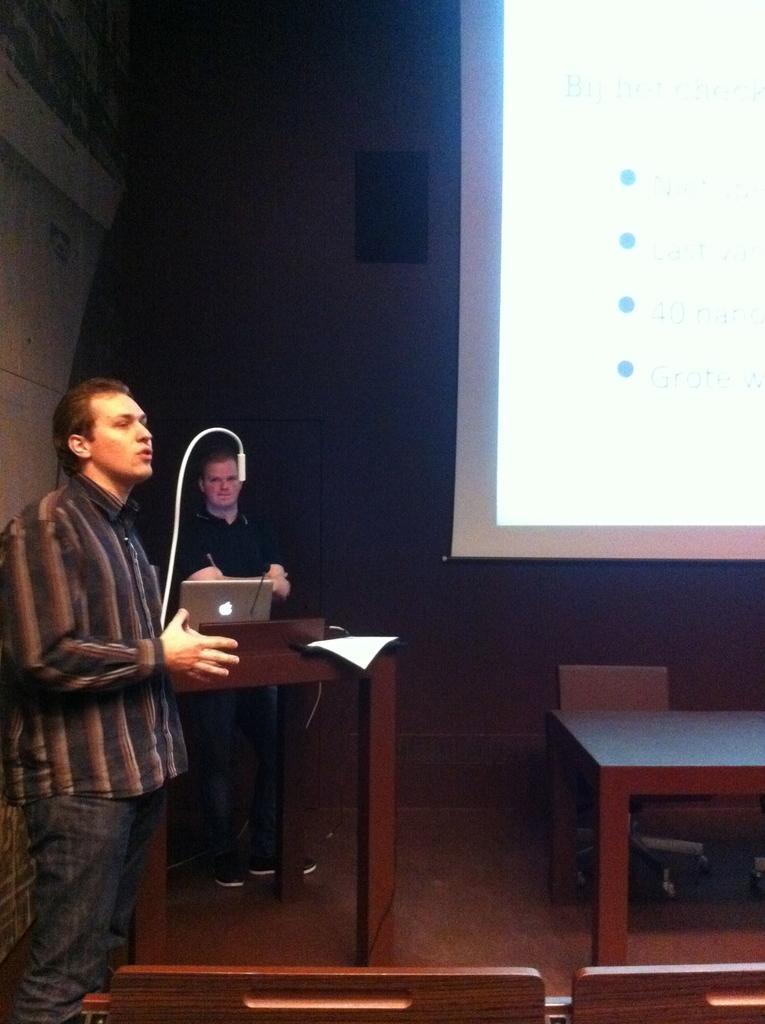How would you summarize this image in a sentence or two? In this image there is a man standing and speaking , another man standing near the podium with a laptop and in back ground there is table, screen , speaker, wall. 